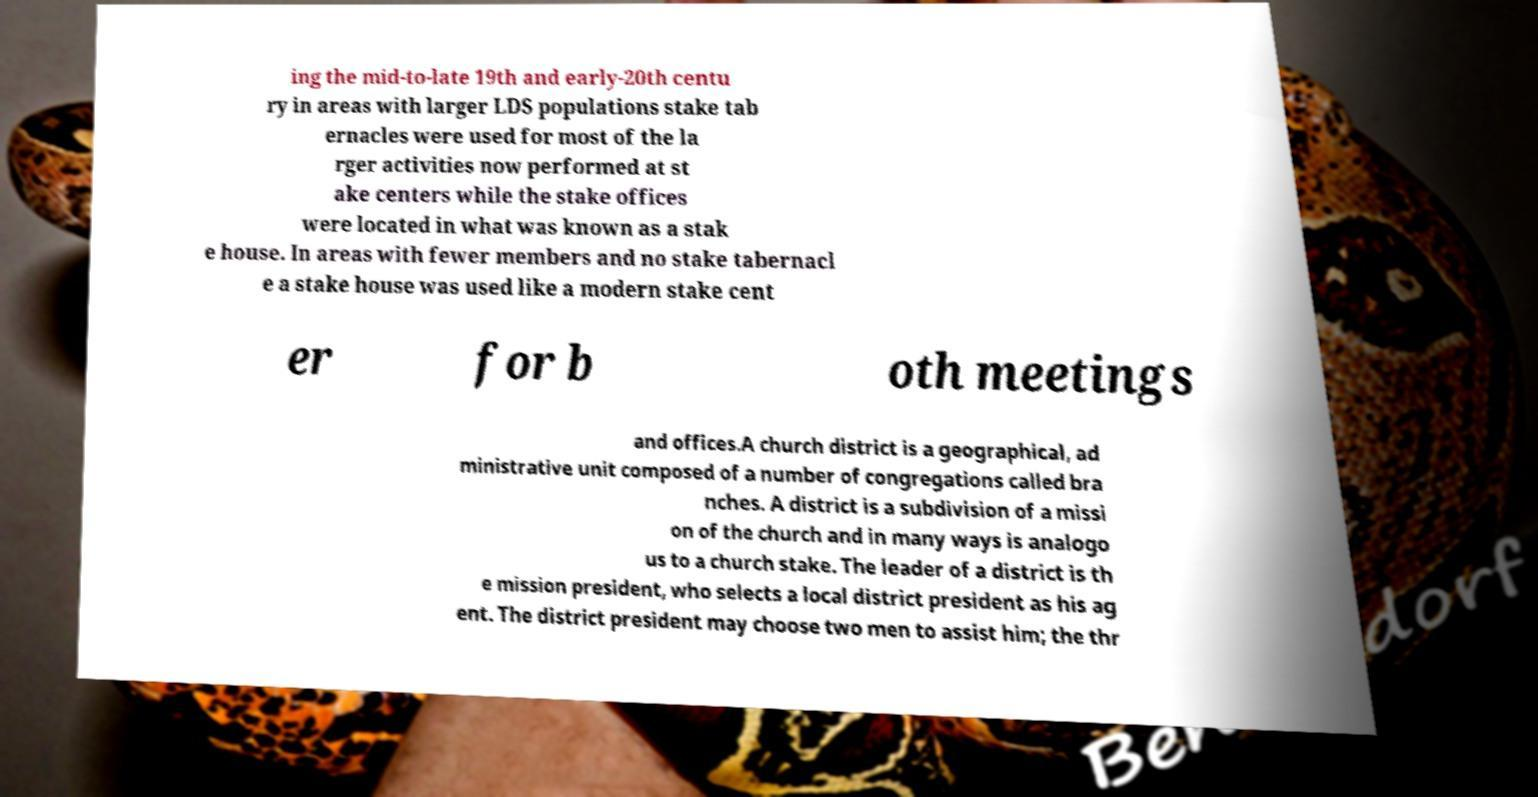Please identify and transcribe the text found in this image. ing the mid-to-late 19th and early-20th centu ry in areas with larger LDS populations stake tab ernacles were used for most of the la rger activities now performed at st ake centers while the stake offices were located in what was known as a stak e house. In areas with fewer members and no stake tabernacl e a stake house was used like a modern stake cent er for b oth meetings and offices.A church district is a geographical, ad ministrative unit composed of a number of congregations called bra nches. A district is a subdivision of a missi on of the church and in many ways is analogo us to a church stake. The leader of a district is th e mission president, who selects a local district president as his ag ent. The district president may choose two men to assist him; the thr 